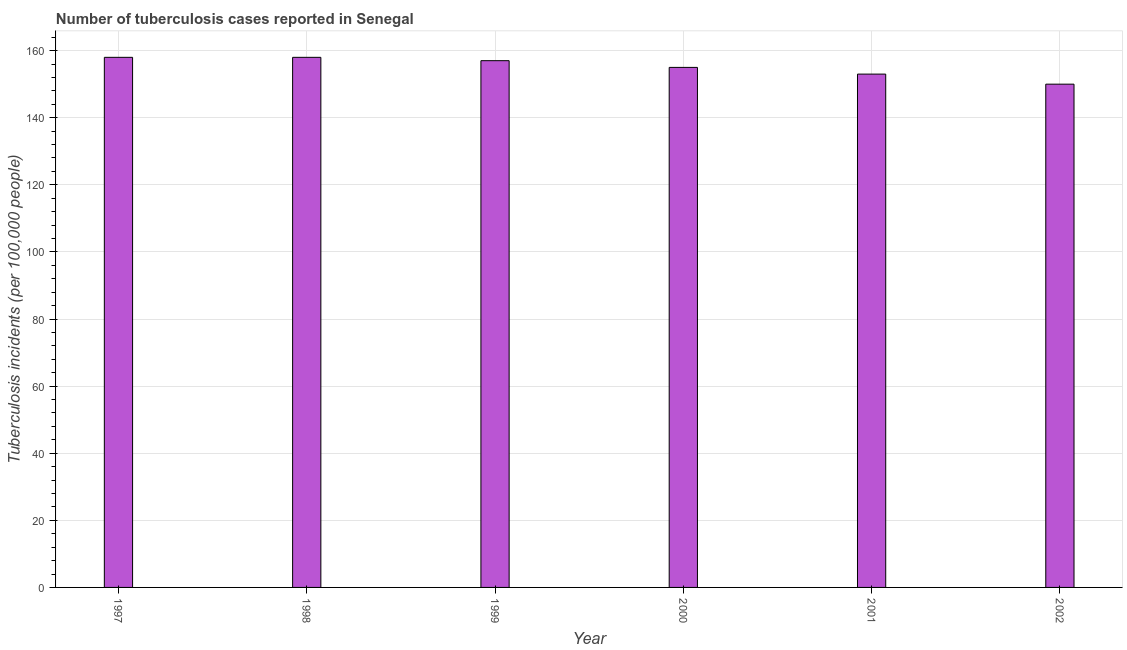What is the title of the graph?
Ensure brevity in your answer.  Number of tuberculosis cases reported in Senegal. What is the label or title of the X-axis?
Provide a succinct answer. Year. What is the label or title of the Y-axis?
Give a very brief answer. Tuberculosis incidents (per 100,0 people). What is the number of tuberculosis incidents in 2002?
Offer a very short reply. 150. Across all years, what is the maximum number of tuberculosis incidents?
Offer a very short reply. 158. Across all years, what is the minimum number of tuberculosis incidents?
Give a very brief answer. 150. In which year was the number of tuberculosis incidents maximum?
Give a very brief answer. 1997. What is the sum of the number of tuberculosis incidents?
Your answer should be compact. 931. What is the average number of tuberculosis incidents per year?
Give a very brief answer. 155. What is the median number of tuberculosis incidents?
Offer a terse response. 156. In how many years, is the number of tuberculosis incidents greater than 152 ?
Make the answer very short. 5. Do a majority of the years between 1999 and 2000 (inclusive) have number of tuberculosis incidents greater than 40 ?
Make the answer very short. Yes. What is the difference between the highest and the second highest number of tuberculosis incidents?
Provide a short and direct response. 0. How many bars are there?
Your response must be concise. 6. How many years are there in the graph?
Ensure brevity in your answer.  6. Are the values on the major ticks of Y-axis written in scientific E-notation?
Your response must be concise. No. What is the Tuberculosis incidents (per 100,000 people) of 1997?
Offer a terse response. 158. What is the Tuberculosis incidents (per 100,000 people) of 1998?
Give a very brief answer. 158. What is the Tuberculosis incidents (per 100,000 people) of 1999?
Provide a short and direct response. 157. What is the Tuberculosis incidents (per 100,000 people) of 2000?
Offer a very short reply. 155. What is the Tuberculosis incidents (per 100,000 people) in 2001?
Provide a short and direct response. 153. What is the Tuberculosis incidents (per 100,000 people) in 2002?
Your response must be concise. 150. What is the difference between the Tuberculosis incidents (per 100,000 people) in 1997 and 1999?
Provide a succinct answer. 1. What is the difference between the Tuberculosis incidents (per 100,000 people) in 1997 and 2001?
Give a very brief answer. 5. What is the difference between the Tuberculosis incidents (per 100,000 people) in 1997 and 2002?
Your answer should be very brief. 8. What is the difference between the Tuberculosis incidents (per 100,000 people) in 1998 and 2000?
Give a very brief answer. 3. What is the difference between the Tuberculosis incidents (per 100,000 people) in 1999 and 2001?
Keep it short and to the point. 4. What is the difference between the Tuberculosis incidents (per 100,000 people) in 2000 and 2001?
Offer a terse response. 2. What is the difference between the Tuberculosis incidents (per 100,000 people) in 2001 and 2002?
Ensure brevity in your answer.  3. What is the ratio of the Tuberculosis incidents (per 100,000 people) in 1997 to that in 2000?
Offer a terse response. 1.02. What is the ratio of the Tuberculosis incidents (per 100,000 people) in 1997 to that in 2001?
Provide a short and direct response. 1.03. What is the ratio of the Tuberculosis incidents (per 100,000 people) in 1997 to that in 2002?
Ensure brevity in your answer.  1.05. What is the ratio of the Tuberculosis incidents (per 100,000 people) in 1998 to that in 2000?
Provide a short and direct response. 1.02. What is the ratio of the Tuberculosis incidents (per 100,000 people) in 1998 to that in 2001?
Your answer should be compact. 1.03. What is the ratio of the Tuberculosis incidents (per 100,000 people) in 1998 to that in 2002?
Your answer should be very brief. 1.05. What is the ratio of the Tuberculosis incidents (per 100,000 people) in 1999 to that in 2002?
Give a very brief answer. 1.05. What is the ratio of the Tuberculosis incidents (per 100,000 people) in 2000 to that in 2002?
Ensure brevity in your answer.  1.03. What is the ratio of the Tuberculosis incidents (per 100,000 people) in 2001 to that in 2002?
Offer a terse response. 1.02. 